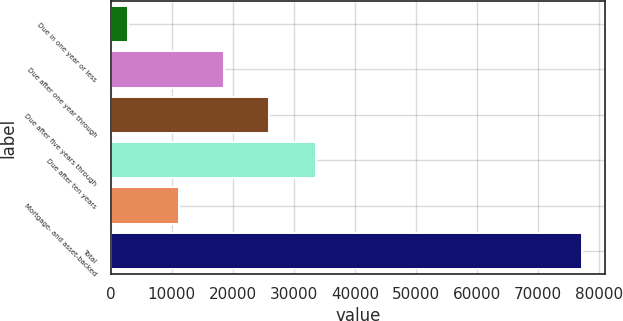Convert chart. <chart><loc_0><loc_0><loc_500><loc_500><bar_chart><fcel>Due in one year or less<fcel>Due after one year through<fcel>Due after five years through<fcel>Due after ten years<fcel>Mortgage- and asset-backed<fcel>Total<nl><fcel>2915<fcel>18563.9<fcel>25982.8<fcel>33656<fcel>11145<fcel>77104<nl></chart> 